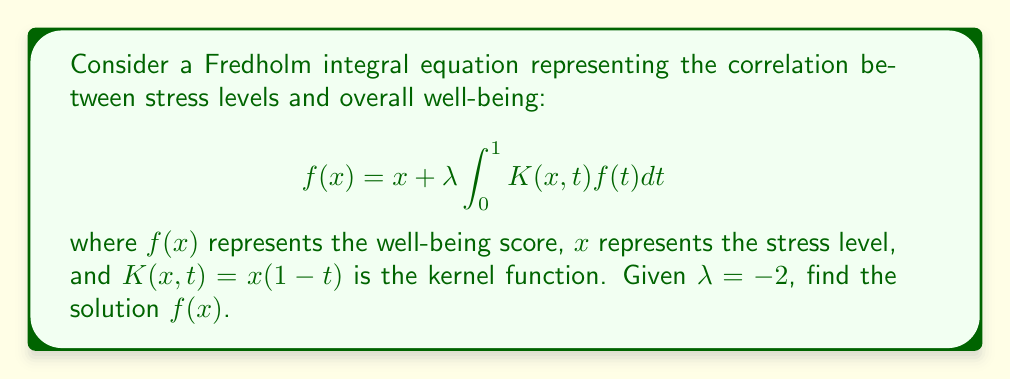Solve this math problem. 1) First, we assume a solution of the form $f(x) = ax + b$, where $a$ and $b$ are constants to be determined.

2) Substitute this into the integral equation:

   $$ax + b = x - 2 \int_0^1 x(1-t)(at + b)dt$$

3) Expand the integrand:

   $$ax + b = x - 2x \int_0^1 (at + b - at^2 - bt)dt$$

4) Evaluate the integral:

   $$ax + b = x - 2x \left[\frac{at}{2} + bt - \frac{at^3}{3} - \frac{bt^2}{2}\right]_0^1$$

   $$ax + b = x - 2x \left(\frac{a}{2} + b - \frac{a}{3} - \frac{b}{2}\right)$$

   $$ax + b = x - 2x \left(\frac{a}{6} + \frac{b}{2}\right)$$

5) Collect terms:

   $$ax + b = x - \frac{ax}{3} - xb$$

6) Equate coefficients of $x$ and constant terms:

   For $x$: $a = 1 - \frac{a}{3} - b$
   Constant: $b = 0$

7) From the constant term, we know $b = 0$. Substitute this into the equation for $a$:

   $a = 1 - \frac{a}{3}$

   $\frac{3a}{3} = 1 - \frac{a}{3}$

   $\frac{4a}{3} = 1$

   $a = \frac{3}{4}$

8) Therefore, the solution is $f(x) = \frac{3}{4}x$.
Answer: $f(x) = \frac{3}{4}x$ 